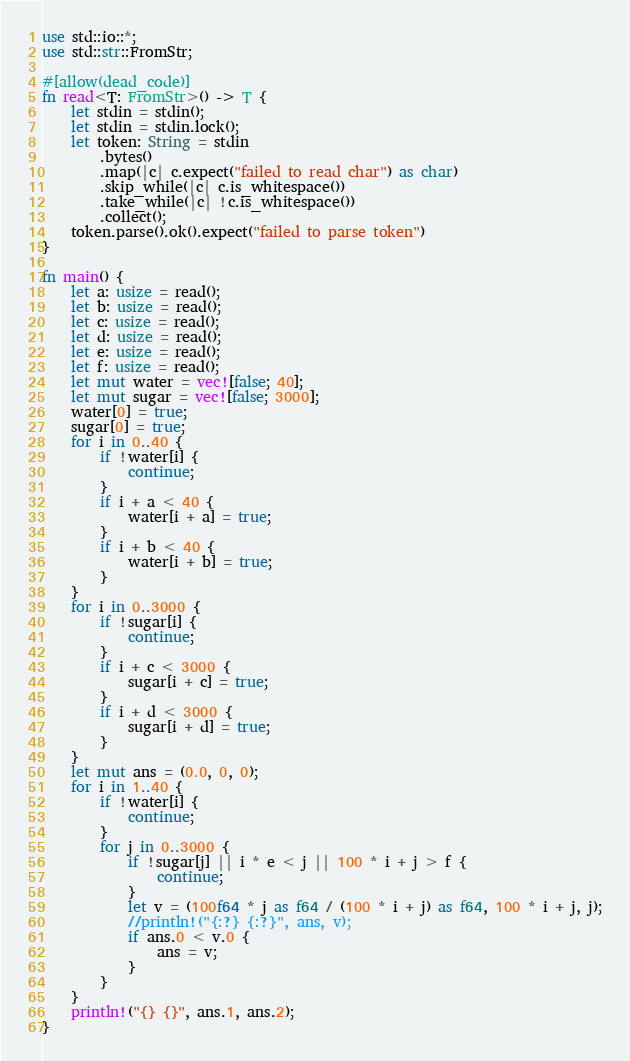Convert code to text. <code><loc_0><loc_0><loc_500><loc_500><_Rust_>use std::io::*;
use std::str::FromStr;

#[allow(dead_code)]
fn read<T: FromStr>() -> T {
    let stdin = stdin();
    let stdin = stdin.lock();
    let token: String = stdin
        .bytes()
        .map(|c| c.expect("failed to read char") as char)
        .skip_while(|c| c.is_whitespace())
        .take_while(|c| !c.is_whitespace())
        .collect();
    token.parse().ok().expect("failed to parse token")
}

fn main() {
    let a: usize = read();
    let b: usize = read();
    let c: usize = read();
    let d: usize = read();
    let e: usize = read();
    let f: usize = read();
    let mut water = vec![false; 40];
    let mut sugar = vec![false; 3000];
    water[0] = true;
    sugar[0] = true;
    for i in 0..40 {
        if !water[i] {
            continue;
        }
        if i + a < 40 {
            water[i + a] = true;
        }
        if i + b < 40 {
            water[i + b] = true;
        }
    }
    for i in 0..3000 {
        if !sugar[i] {
            continue;
        }
        if i + c < 3000 {
            sugar[i + c] = true;
        }
        if i + d < 3000 {
            sugar[i + d] = true;
        }
    }
    let mut ans = (0.0, 0, 0);
    for i in 1..40 {
        if !water[i] {
            continue;
        }
        for j in 0..3000 {
            if !sugar[j] || i * e < j || 100 * i + j > f {
                continue;
            }
            let v = (100f64 * j as f64 / (100 * i + j) as f64, 100 * i + j, j);
            //println!("{:?} {:?}", ans, v);
            if ans.0 < v.0 {
                ans = v;
            }
        }
    }
    println!("{} {}", ans.1, ans.2);
}
</code> 